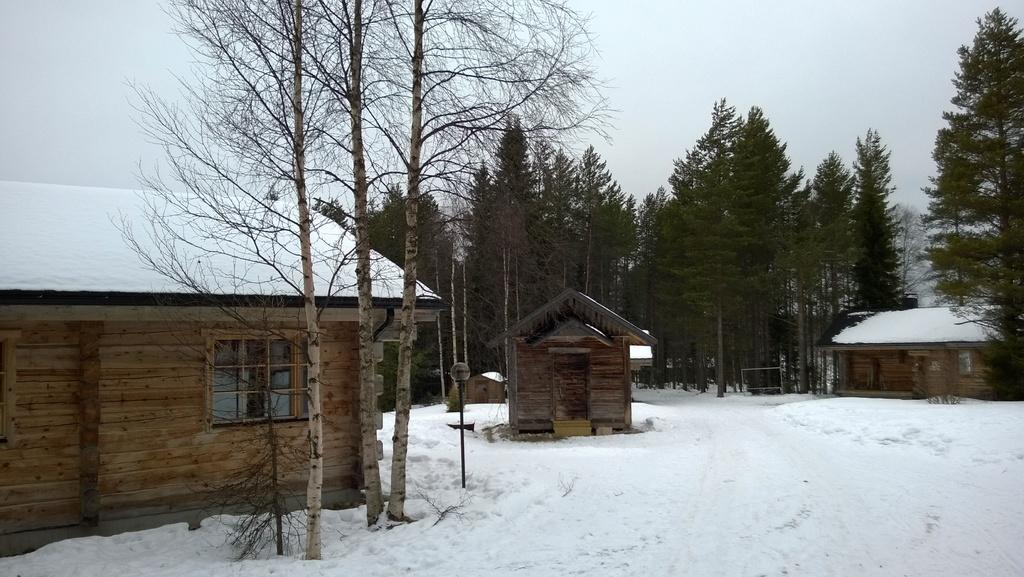What type of structures can be seen in the image? There are buildings in the image. What other natural elements are present in the image? There are trees in the image. What is the condition of the ground in the image? There is snow on the ground in the image. What is the weather like in the image? The sky is clear in the image, indicating a clear day. Where is the vase located in the image? There is no vase present in the image. What type of calculations can be performed using the calculator in the image? There is no calculator present in the image. 